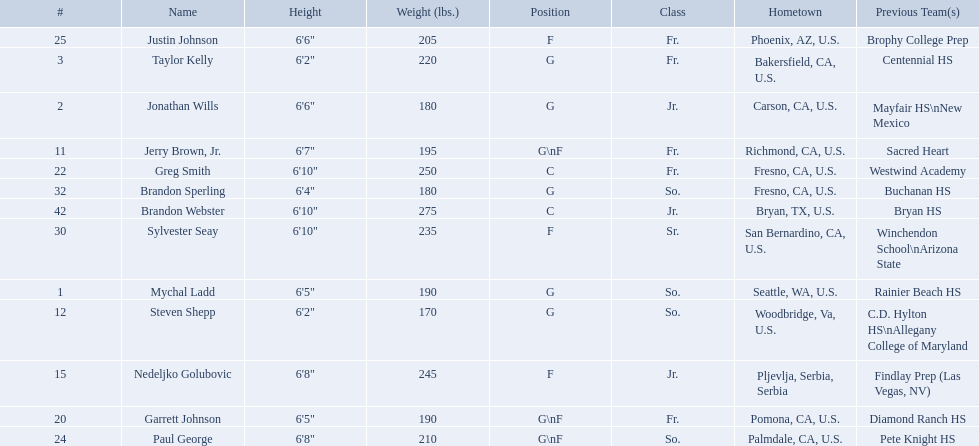Who are all the players in the 2009-10 fresno state bulldogs men's basketball team? Mychal Ladd, Jonathan Wills, Taylor Kelly, Jerry Brown, Jr., Steven Shepp, Nedeljko Golubovic, Garrett Johnson, Greg Smith, Paul George, Justin Johnson, Sylvester Seay, Brandon Sperling, Brandon Webster. Of these players, who are the ones who play forward? Jerry Brown, Jr., Nedeljko Golubovic, Garrett Johnson, Paul George, Justin Johnson, Sylvester Seay. Of these players, which ones only play forward and no other position? Nedeljko Golubovic, Justin Johnson, Sylvester Seay. Of these players, who is the shortest? Justin Johnson. Which positions are so.? G, G, G\nF, G. Which weights are g 190, 170, 180. What height is under 6 3' 6'2". What is the name Steven Shepp. 